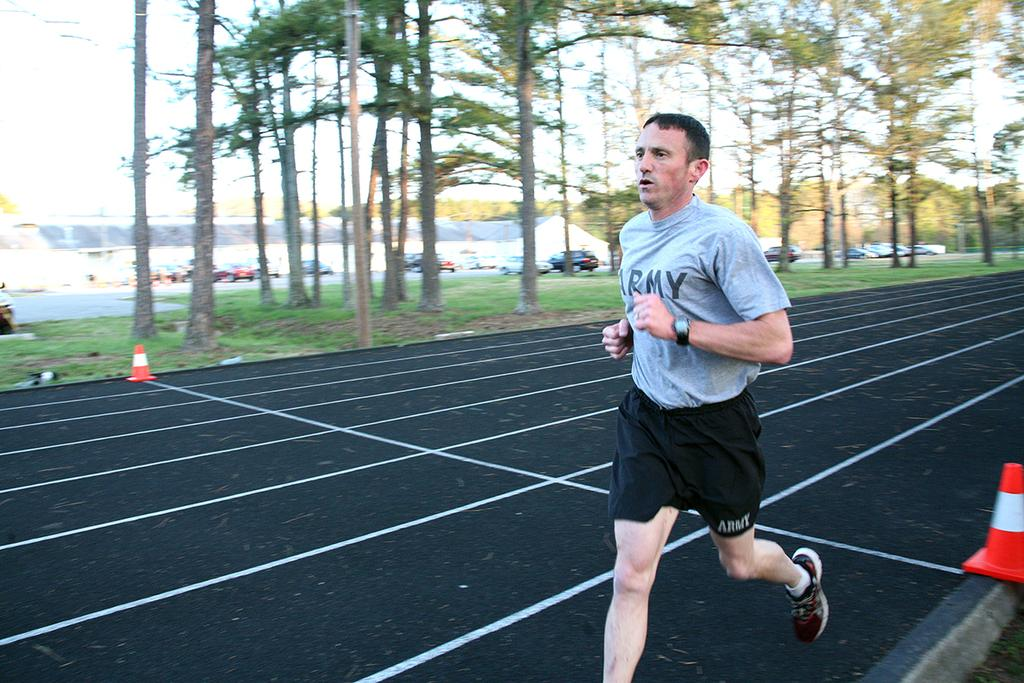<image>
Offer a succinct explanation of the picture presented. A man wearing a grey Army shirt is running on a track. 